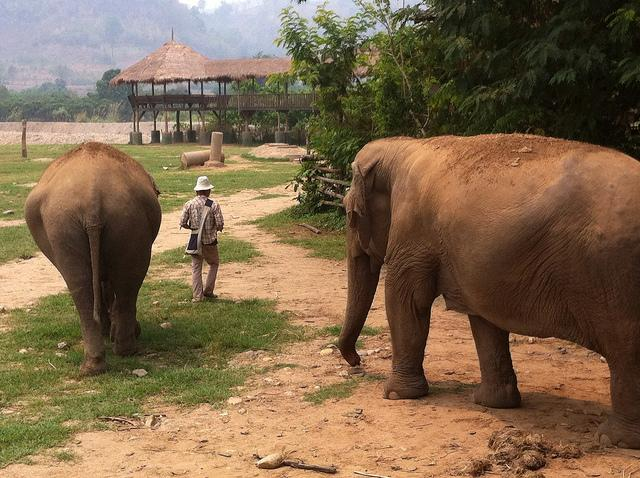How many elephants are following after the man wearing a white hat? Please explain your reasoning. two. The animals are clearly visible and located behind the man in the image. they are countable based on their outlines. 